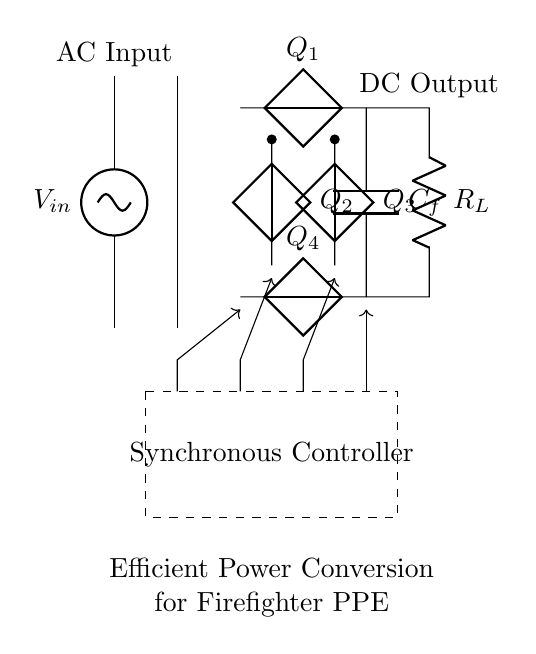What is the input component of this circuit? The input component is a voltage source labeled V in, supplying alternating current to the circuit.
Answer: V in What is the purpose of the transformer in this circuit? The transformer is used to step up or step down the voltage level coming from the AC input before it reaches the rectifier bridge.
Answer: Voltage adjustment How many diodes are used in the rectifier bridge? There are four diodes used, labeled as Q1, Q2, Q3, and Q4, forming a full bridge for rectification.
Answer: Four What does the dashed rectangle represent? The dashed rectangle represents the synchronous controller, which manages the operation of the rectifier, ensuring efficient power conversion.
Answer: Synchronous Controller What is the role of the output capacitor in this circuit? The output capacitor, labeled Cf, smooths the rectified output voltage by filtering out ripples, providing a steadier DC output.
Answer: Smoothing How does the synchronous controller influence the efficiency of this circuit? The synchronous controller actively switches the diodes, reducing conduction losses and improving overall efficiency in converting AC to DC.
Answer: Reduces losses What is the output of this synchronous rectifier circuit? The output is direct current voltage that can be used to power the electronics integrated into firefighter PPE.
Answer: DC Output 